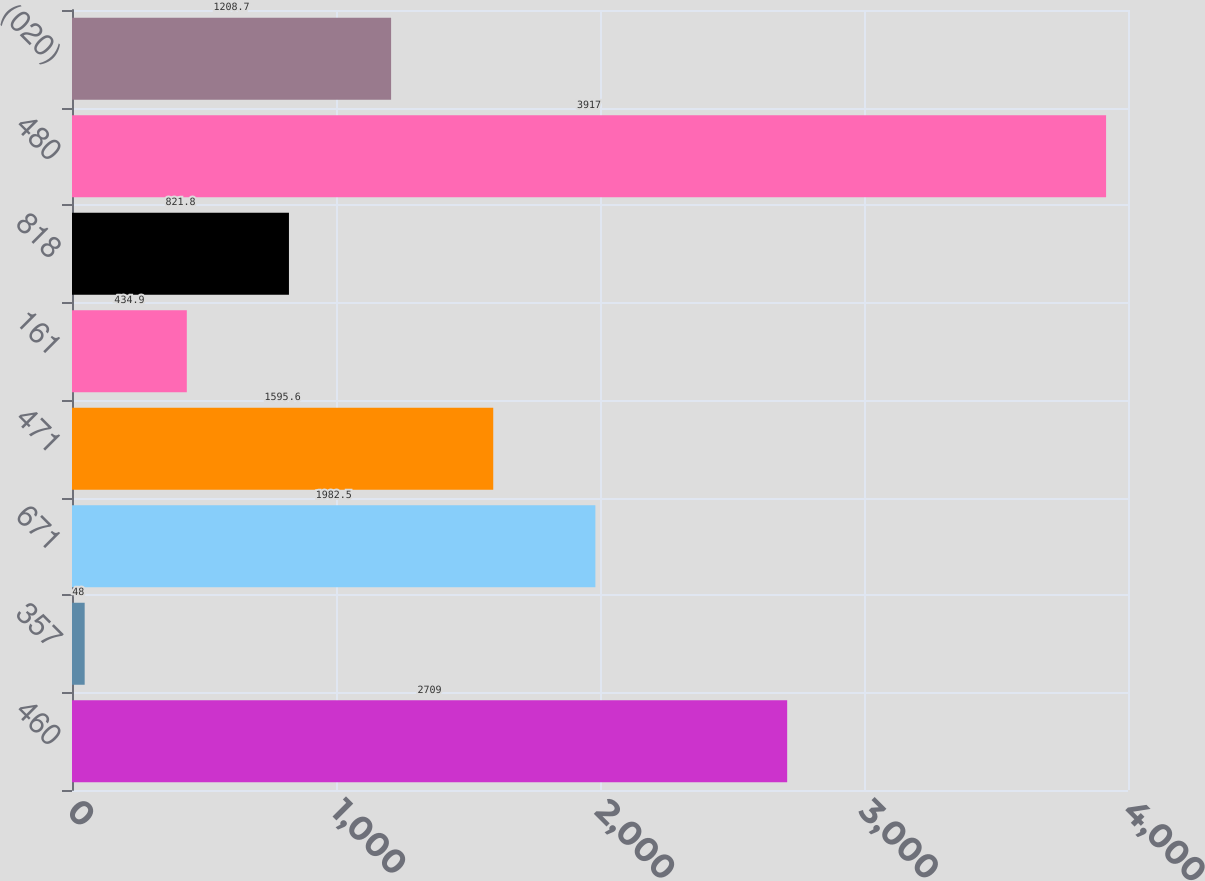Convert chart to OTSL. <chart><loc_0><loc_0><loc_500><loc_500><bar_chart><fcel>460<fcel>357<fcel>671<fcel>471<fcel>161<fcel>818<fcel>480<fcel>(020)<nl><fcel>2709<fcel>48<fcel>1982.5<fcel>1595.6<fcel>434.9<fcel>821.8<fcel>3917<fcel>1208.7<nl></chart> 